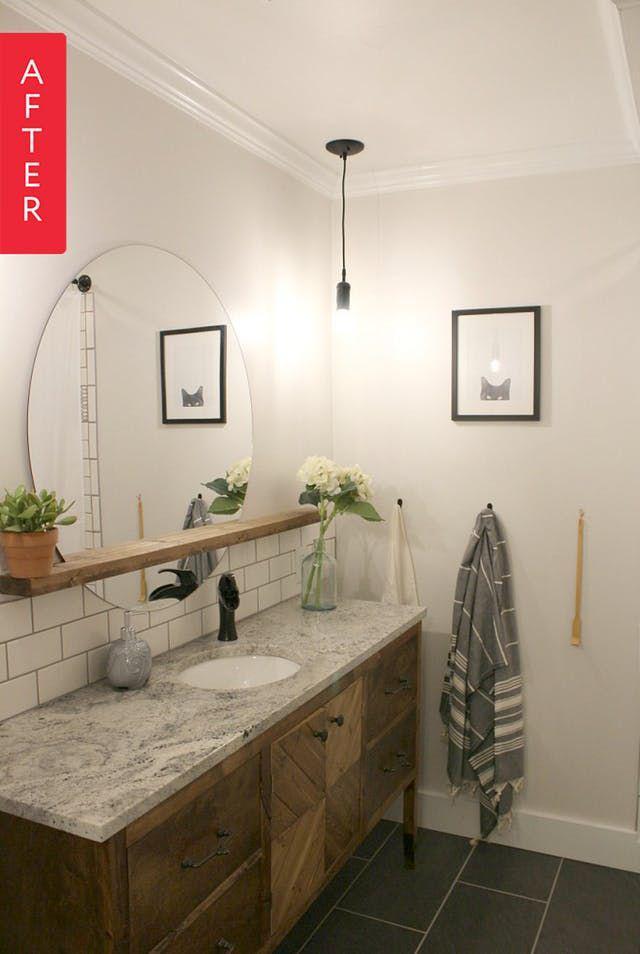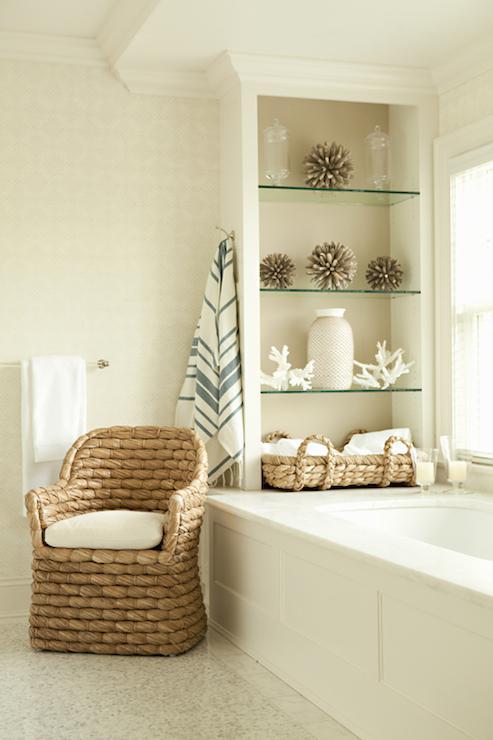The first image is the image on the left, the second image is the image on the right. For the images shown, is this caption "A porcelain pitcher is shown by something made of fabric in one image." true? Answer yes or no. No. The first image is the image on the left, the second image is the image on the right. For the images shown, is this caption "The outside can be seen in the image on the left." true? Answer yes or no. No. 